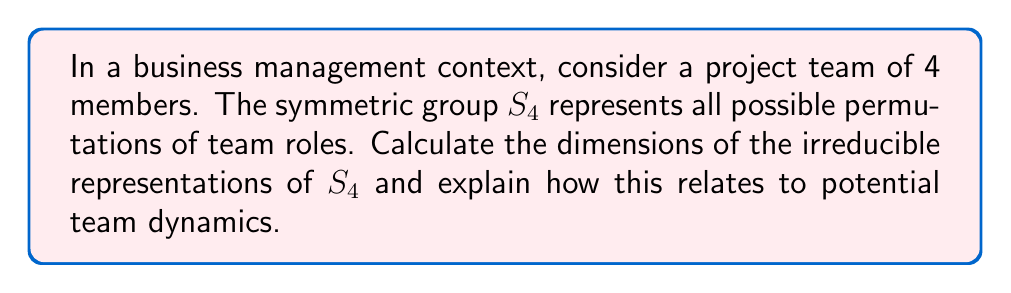Provide a solution to this math problem. To solve this problem, we'll follow these steps:

1. Recall that the irreducible representations of $S_n$ correspond to partitions of $n$.

2. For $S_4$, the partitions are:
   [4], [3,1], [2,2], [2,1,1], [1,1,1,1]

3. To calculate the dimensions, we use the hook length formula:
   $$\text{dim}(\lambda) = \frac{n!}{\prod_{(i,j) \in \lambda} h(i,j)}$$
   where $h(i,j)$ is the hook length of the cell $(i,j)$ in the Young diagram.

4. Calculate dimensions for each partition:

   [4]: $\frac{4!}{4} = 1$
   
   [3,1]: $\frac{4!}{4 \cdot 1} = 3$
   
   [2,2]: $\frac{4!}{3 \cdot 2} = 2$
   
   [2,1,1]: $\frac{4!}{3 \cdot 1 \cdot 1} = 3$
   
   [1,1,1,1]: $\frac{4!}{4 \cdot 3 \cdot 2 \cdot 1} = 1$

5. Relate to team dynamics:
   - Dimension 1: Trivial and sign representations (full consensus or complete disagreement)
   - Dimension 2: Balanced subgroups within the team
   - Dimension 3: Leadership dynamics (one leader with three followers, or one outsider with three collaborators)

This analysis provides insights into potential team interaction patterns and decision-making structures.
Answer: Dimensions: 1, 3, 2, 3, 1. These represent different team interaction patterns: full consensus/disagreement (1), leadership dynamics (3), balanced subgroups (2). 